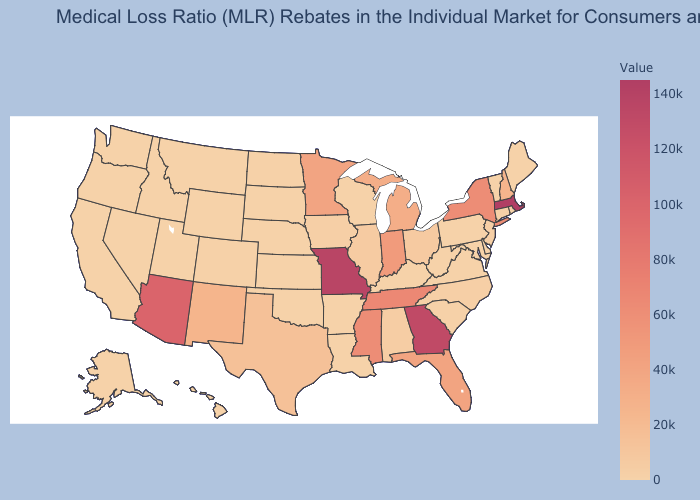Is the legend a continuous bar?
Short answer required. Yes. Does New Mexico have a higher value than Washington?
Be succinct. Yes. 